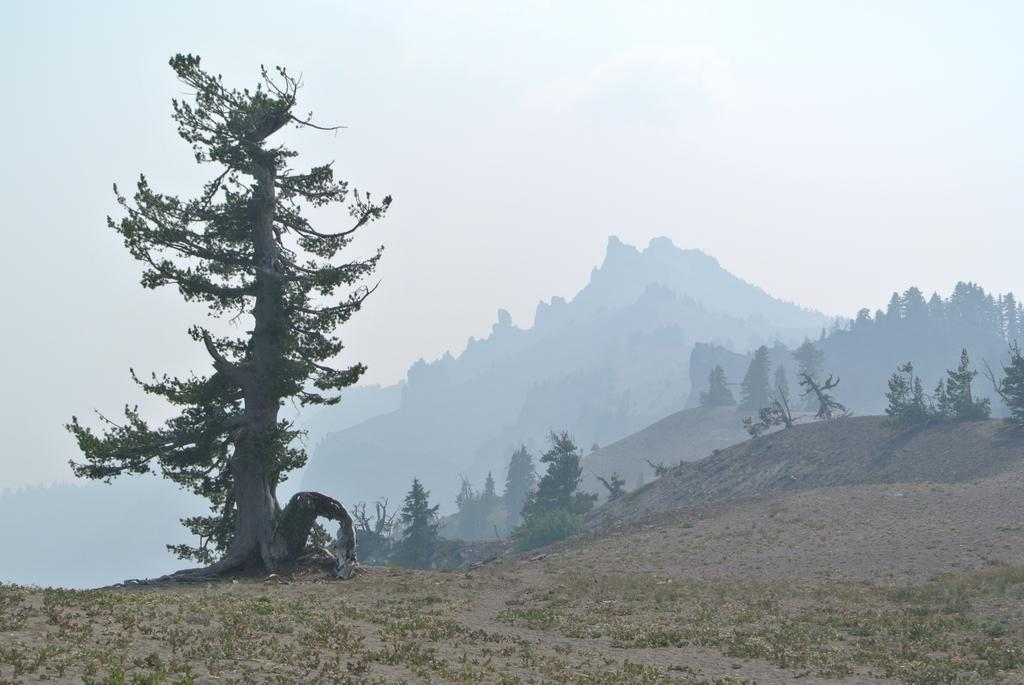What type of vegetation is present in the image? There is a tree and grass on the ground in the image. What can be seen on the ground in the image? There is grass on the ground in the image. What is visible in the background of the image? There are trees, hills, and the sky visible in the background of the image. How far away is the tank from the tree in the image? There is no tank present in the image, so it is not possible to determine the distance between a tank and the tree. 